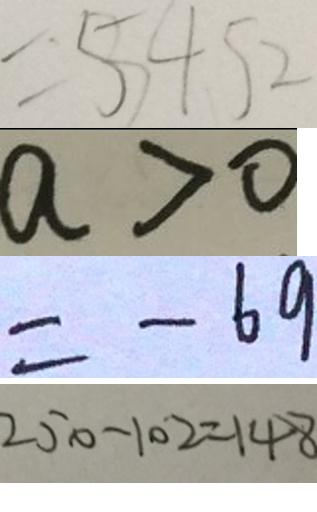<formula> <loc_0><loc_0><loc_500><loc_500>= 5 4 5 2 
 a > 0 
 = - 6 9 
 2 5 0 - 1 0 2 = 1 4 8</formula> 